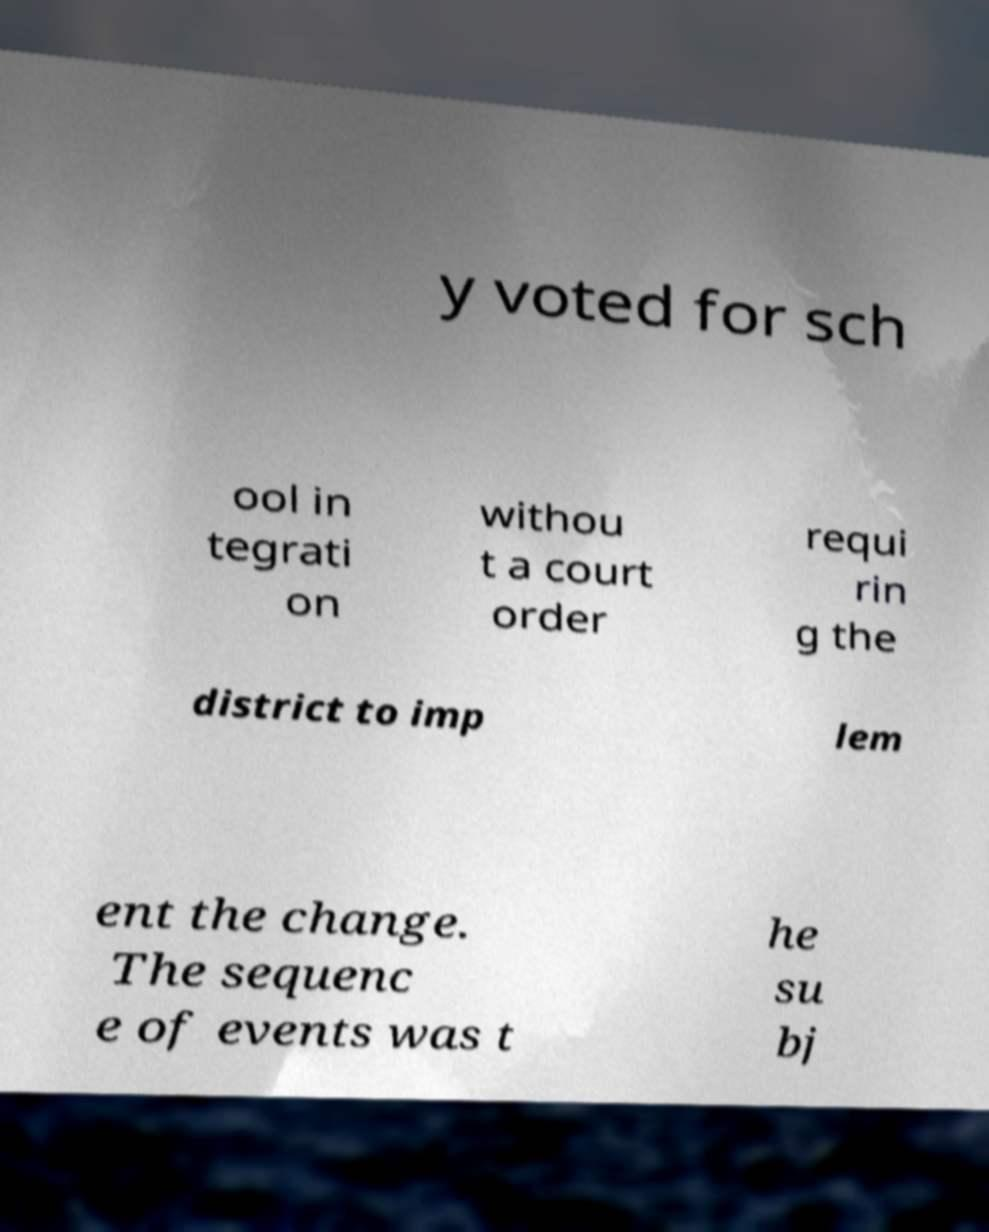Can you accurately transcribe the text from the provided image for me? y voted for sch ool in tegrati on withou t a court order requi rin g the district to imp lem ent the change. The sequenc e of events was t he su bj 